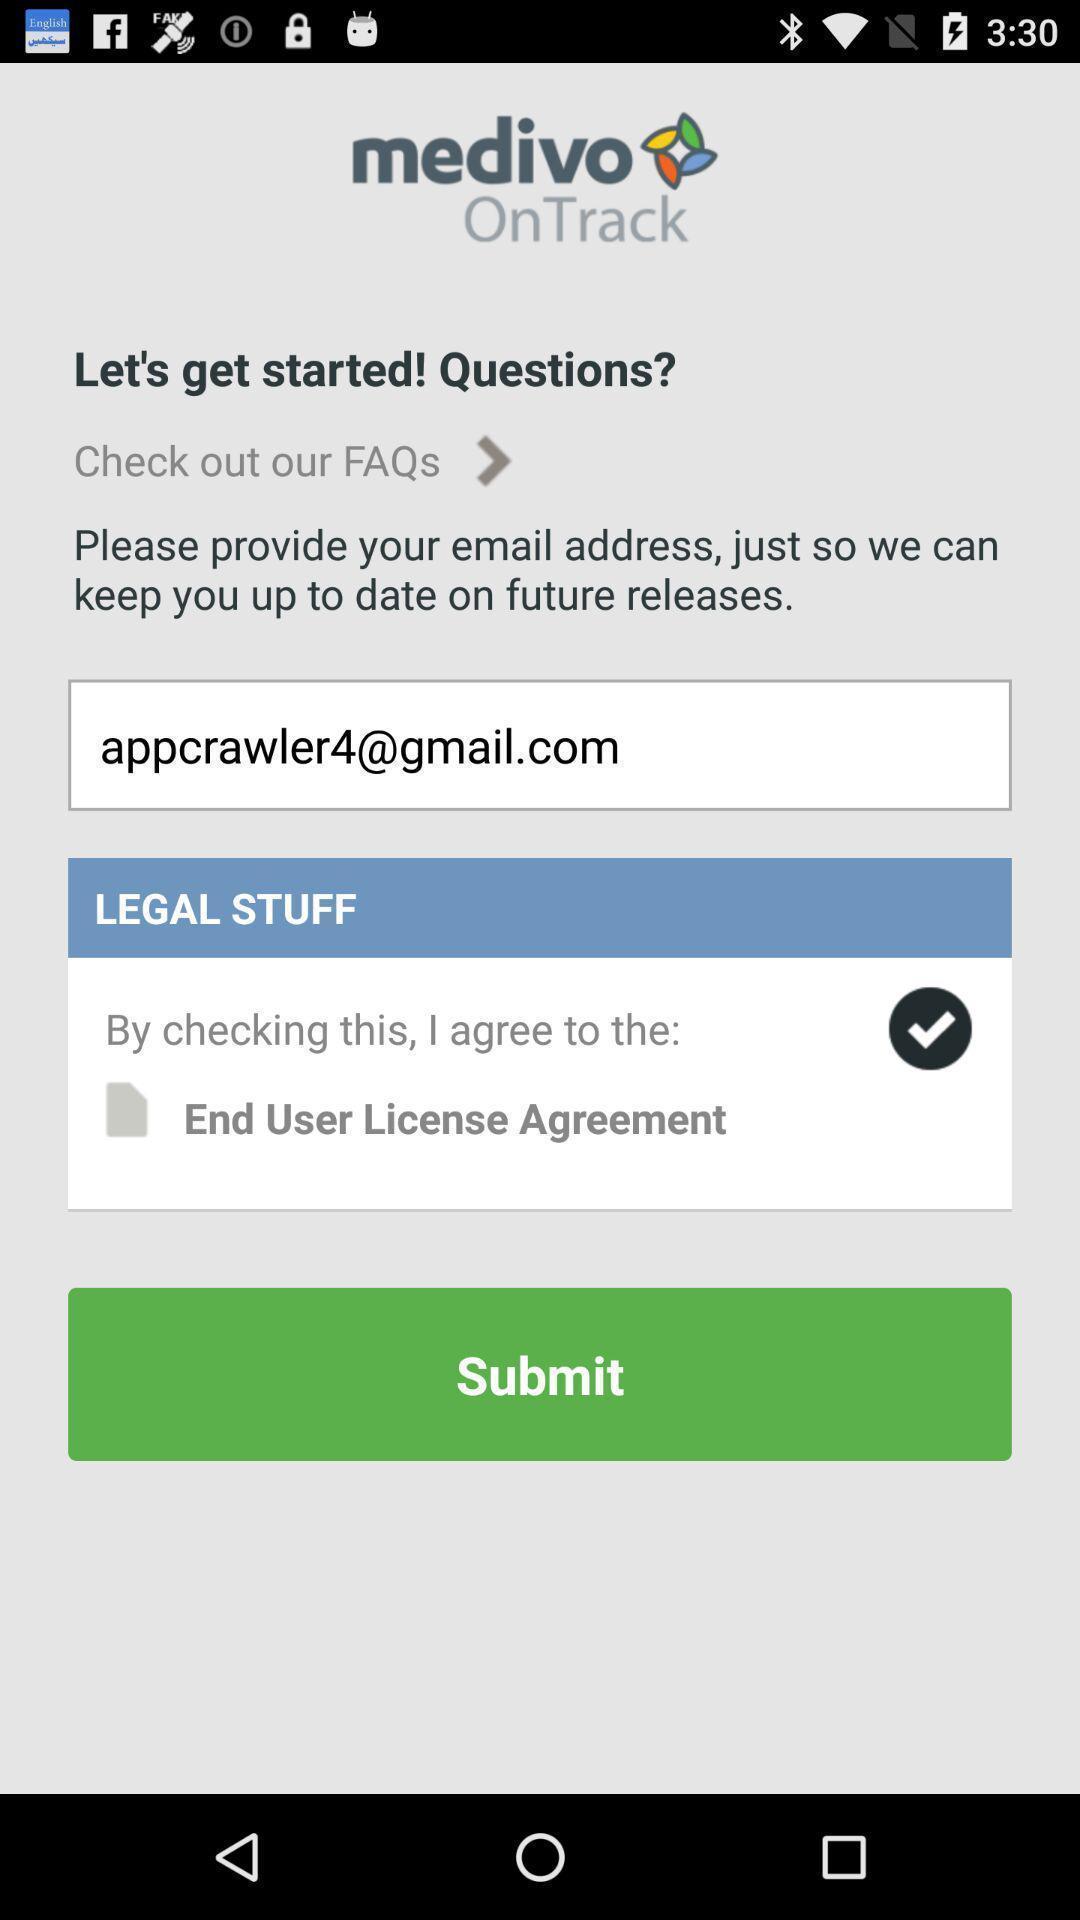Provide a detailed account of this screenshot. Submit page. 